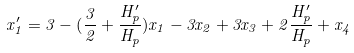Convert formula to latex. <formula><loc_0><loc_0><loc_500><loc_500>x _ { 1 } ^ { \prime } = 3 - ( \frac { 3 } { 2 } + \frac { H _ { p } ^ { \prime } } { H _ { p } } ) x _ { 1 } - 3 x _ { 2 } + 3 x _ { 3 } + 2 \frac { H _ { p } ^ { \prime } } { H _ { p } } + x _ { 4 }</formula> 